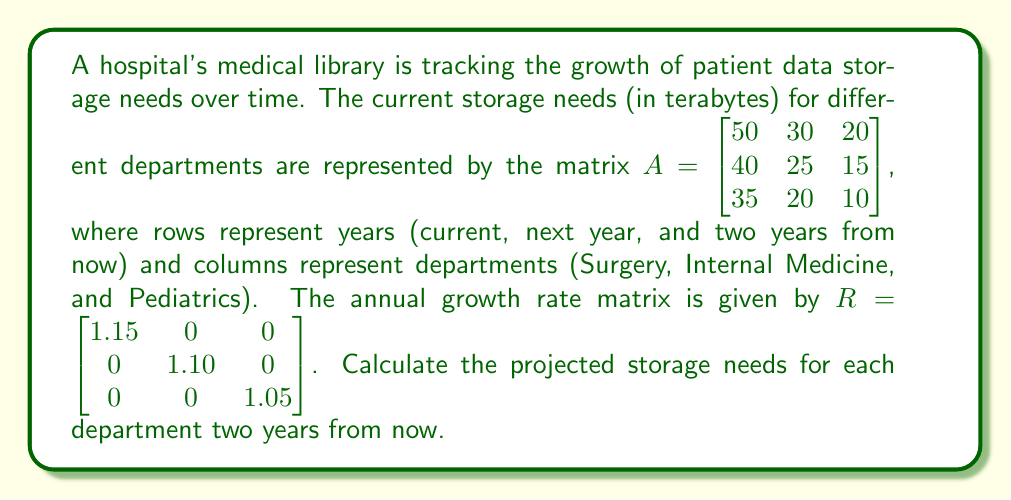What is the answer to this math problem? To solve this problem, we need to use matrix multiplication. The growth rate matrix $R$ needs to be applied twice to the initial storage needs matrix $A$ to project two years into the future.

Step 1: Calculate the storage needs after one year
Let's call this matrix $B$. We calculate it as follows:
$B = AR = \begin{bmatrix} 50 & 30 & 20 \\ 40 & 25 & 15 \\ 35 & 20 & 10 \end{bmatrix} \begin{bmatrix} 1.15 & 0 & 0 \\ 0 & 1.10 & 0 \\ 0 & 0 & 1.05 \end{bmatrix}$

Performing the matrix multiplication:
$B = \begin{bmatrix} 57.5 & 33 & 21 \\ 46 & 27.5 & 15.75 \\ 40.25 & 22 & 10.5 \end{bmatrix}$

Step 2: Calculate the storage needs after two years
We apply the growth rate matrix again to $B$:
$C = BR = \begin{bmatrix} 57.5 & 33 & 21 \\ 46 & 27.5 & 15.75 \\ 40.25 & 22 & 10.5 \end{bmatrix} \begin{bmatrix} 1.15 & 0 & 0 \\ 0 & 1.10 & 0 \\ 0 & 0 & 1.05 \end{bmatrix}$

Performing the matrix multiplication:
$C = \begin{bmatrix} 66.125 & 36.3 & 22.05 \\ 52.9 & 30.25 & 16.5375 \\ 46.2875 & 24.2 & 11.025 \end{bmatrix}$

The last row of matrix $C$ represents the projected storage needs for each department two years from now.
Answer: The projected storage needs (in terabytes) for each department two years from now are:
Surgery: 46.2875 TB
Internal Medicine: 24.2 TB
Pediatrics: 11.025 TB 